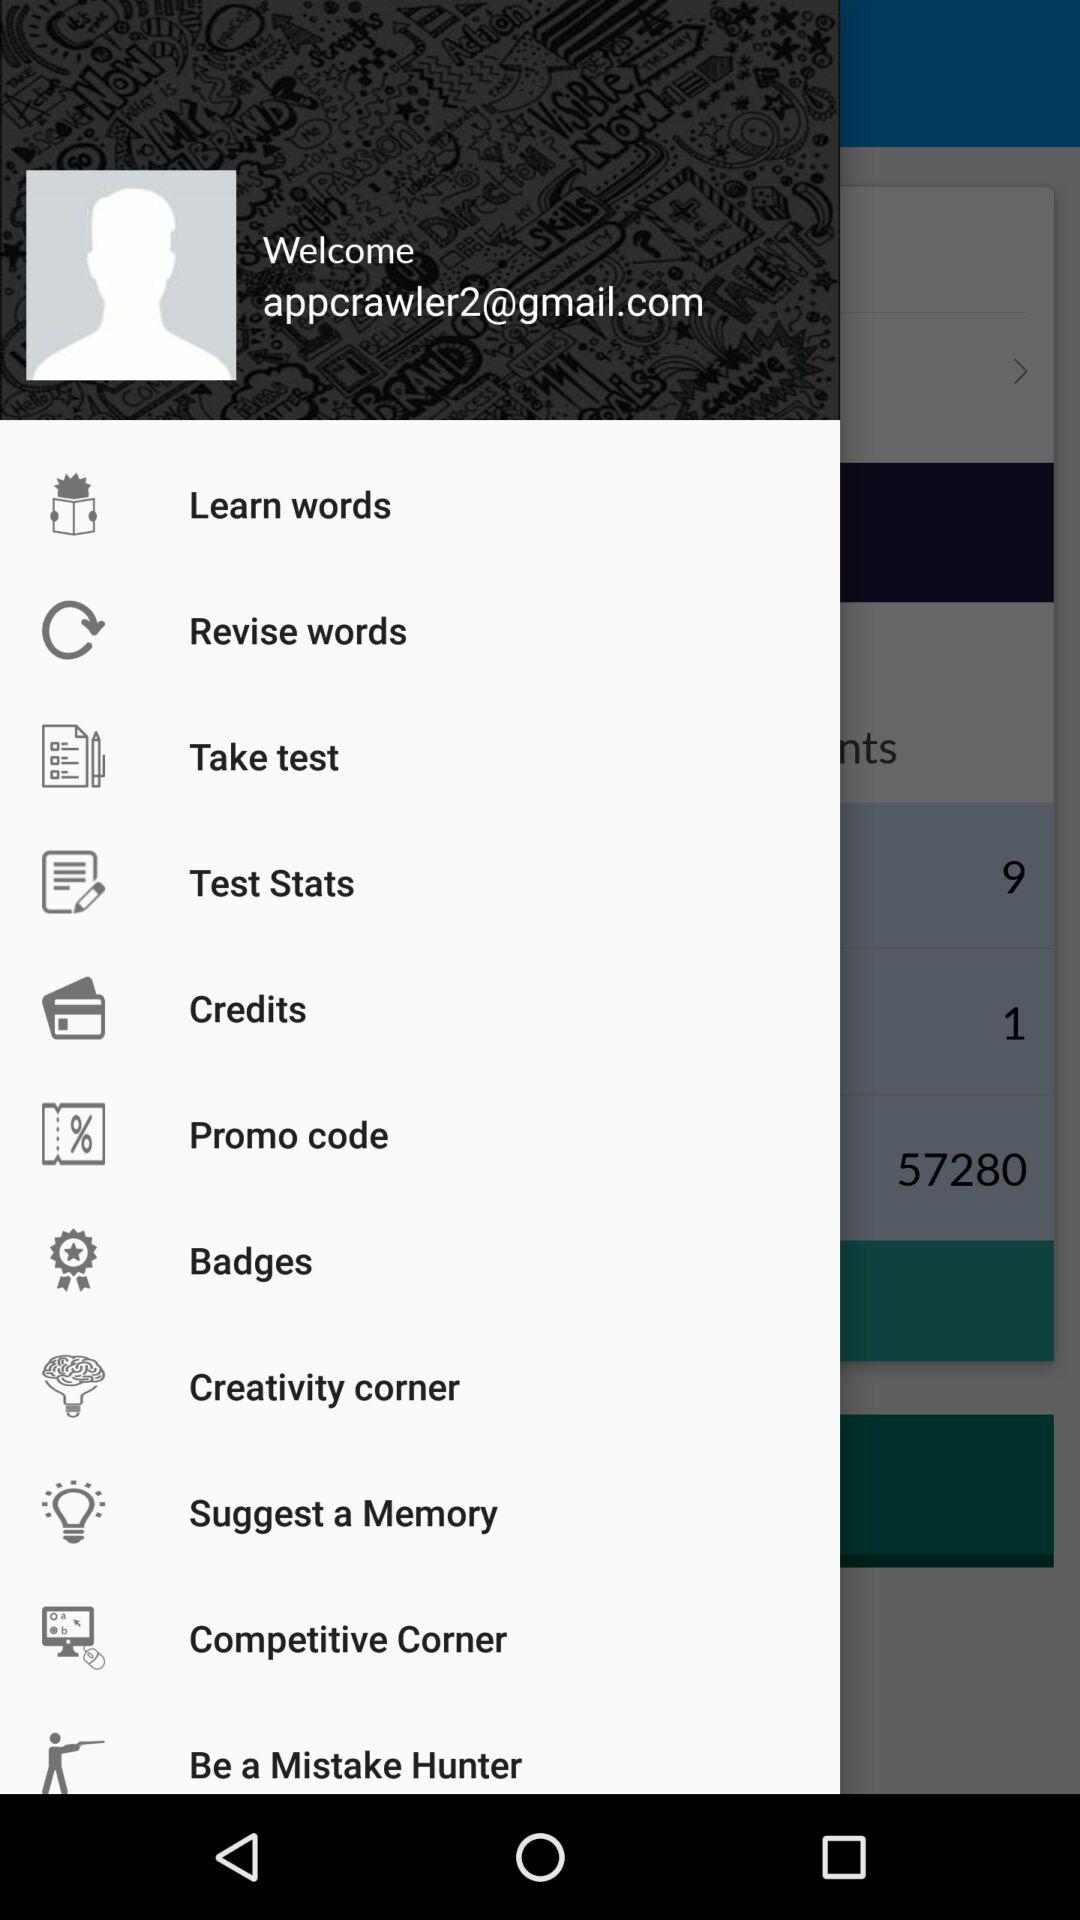What is the mentioned email address? The mentioned email address is appcrawler2@gmail.com. 